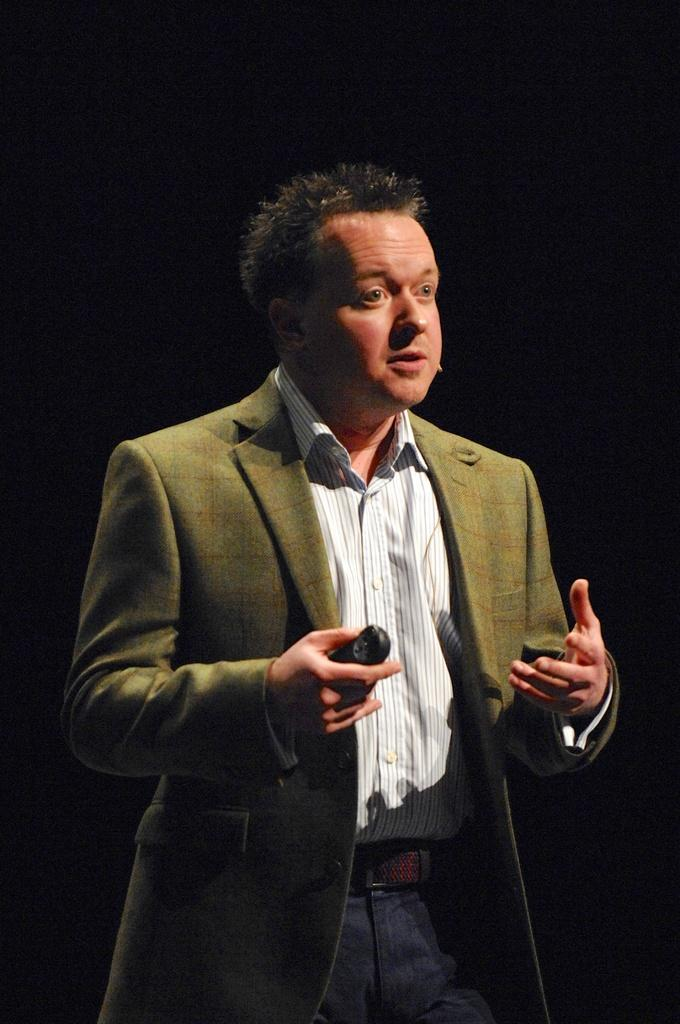What is the main subject of the image? The main subject of the image is a man. What is the man doing in the image? The man is standing in the image. What is the man holding in the image? The man is holding an object in the image. What can be observed about the background of the image? The background of the image is dark. What type of creature can be seen bursting through the wall in the image? There is no creature bursting through the wall in the image. The image only shows a man standing and holding an object, with a dark background. 